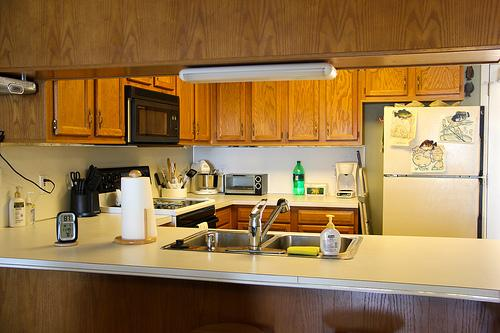Provide a short description of the kitchen scene in the image. A well-equipped kitchen with appliances like a refrigerator, microwave, coffee maker, and gas range, featuring a stainless steel sink, wooden cabinets, and countertops with various items, like a green soda bottle, utensils, and paper towels. How many objects are mentioned in the image? There are 39 objects mentioned in the image. Analyze the relationship between the sink and the objects around it. The sink has a silver faucet, yellow sponge, and container of liquid soap nearby, indicating that it is used for washing and cleaning tasks in the kitchen. List three objects on the countertop and their colors. Coffee maker (black), green soda bottle, white paper towel roll in wooden holder Where can you find the utensils in the kitchen? In a round container on the countertop What is hanging on the refrigerator door? Drawings Where is the microwave located? Underneath the cabinet Read and describe the objects that are on the kitchen counter. Green soda bottle, coffee maker, paper towel roll in wooden holder Create a complete sentence to describe the light fixture mounted under the cabinet. The overhead white light fixture is mounted under the wooden cabinets in the kitchen. What is the color of the microwave? Black Describe the refrigerator. White refrigerator with two doors and paper markings What type of material is used for the sink? Stainless steel Which two colors describe the soap container? White and yellow Choose the correct description of the soda bottle: (A) red opaque soda bottle, (B) green clear soda bottle, (C) blue metallic soda bottle (B) green clear soda bottle Describe the sponge on the sink. Yellow sponge Form a sentence presenting information about the gas range. The gas range has four burners and a white top. Name two items located next to the sink. Yellow sponge and container of liquid soap List three objects on the kitchen countertop. Coffee maker, paper towel roll in wooden holder, green soda bottle Describe the cabinets above the kitchen counter. Brown wooden cabinets What is the color of the toaster oven? Black and silver Identify an object on the countertop that is used for making beverages. Coffee maker Identify the activity that would occur near the sink. Washing dishes What is the purpose of the wooden object holding the paper towels? It is a paper towel holder. 